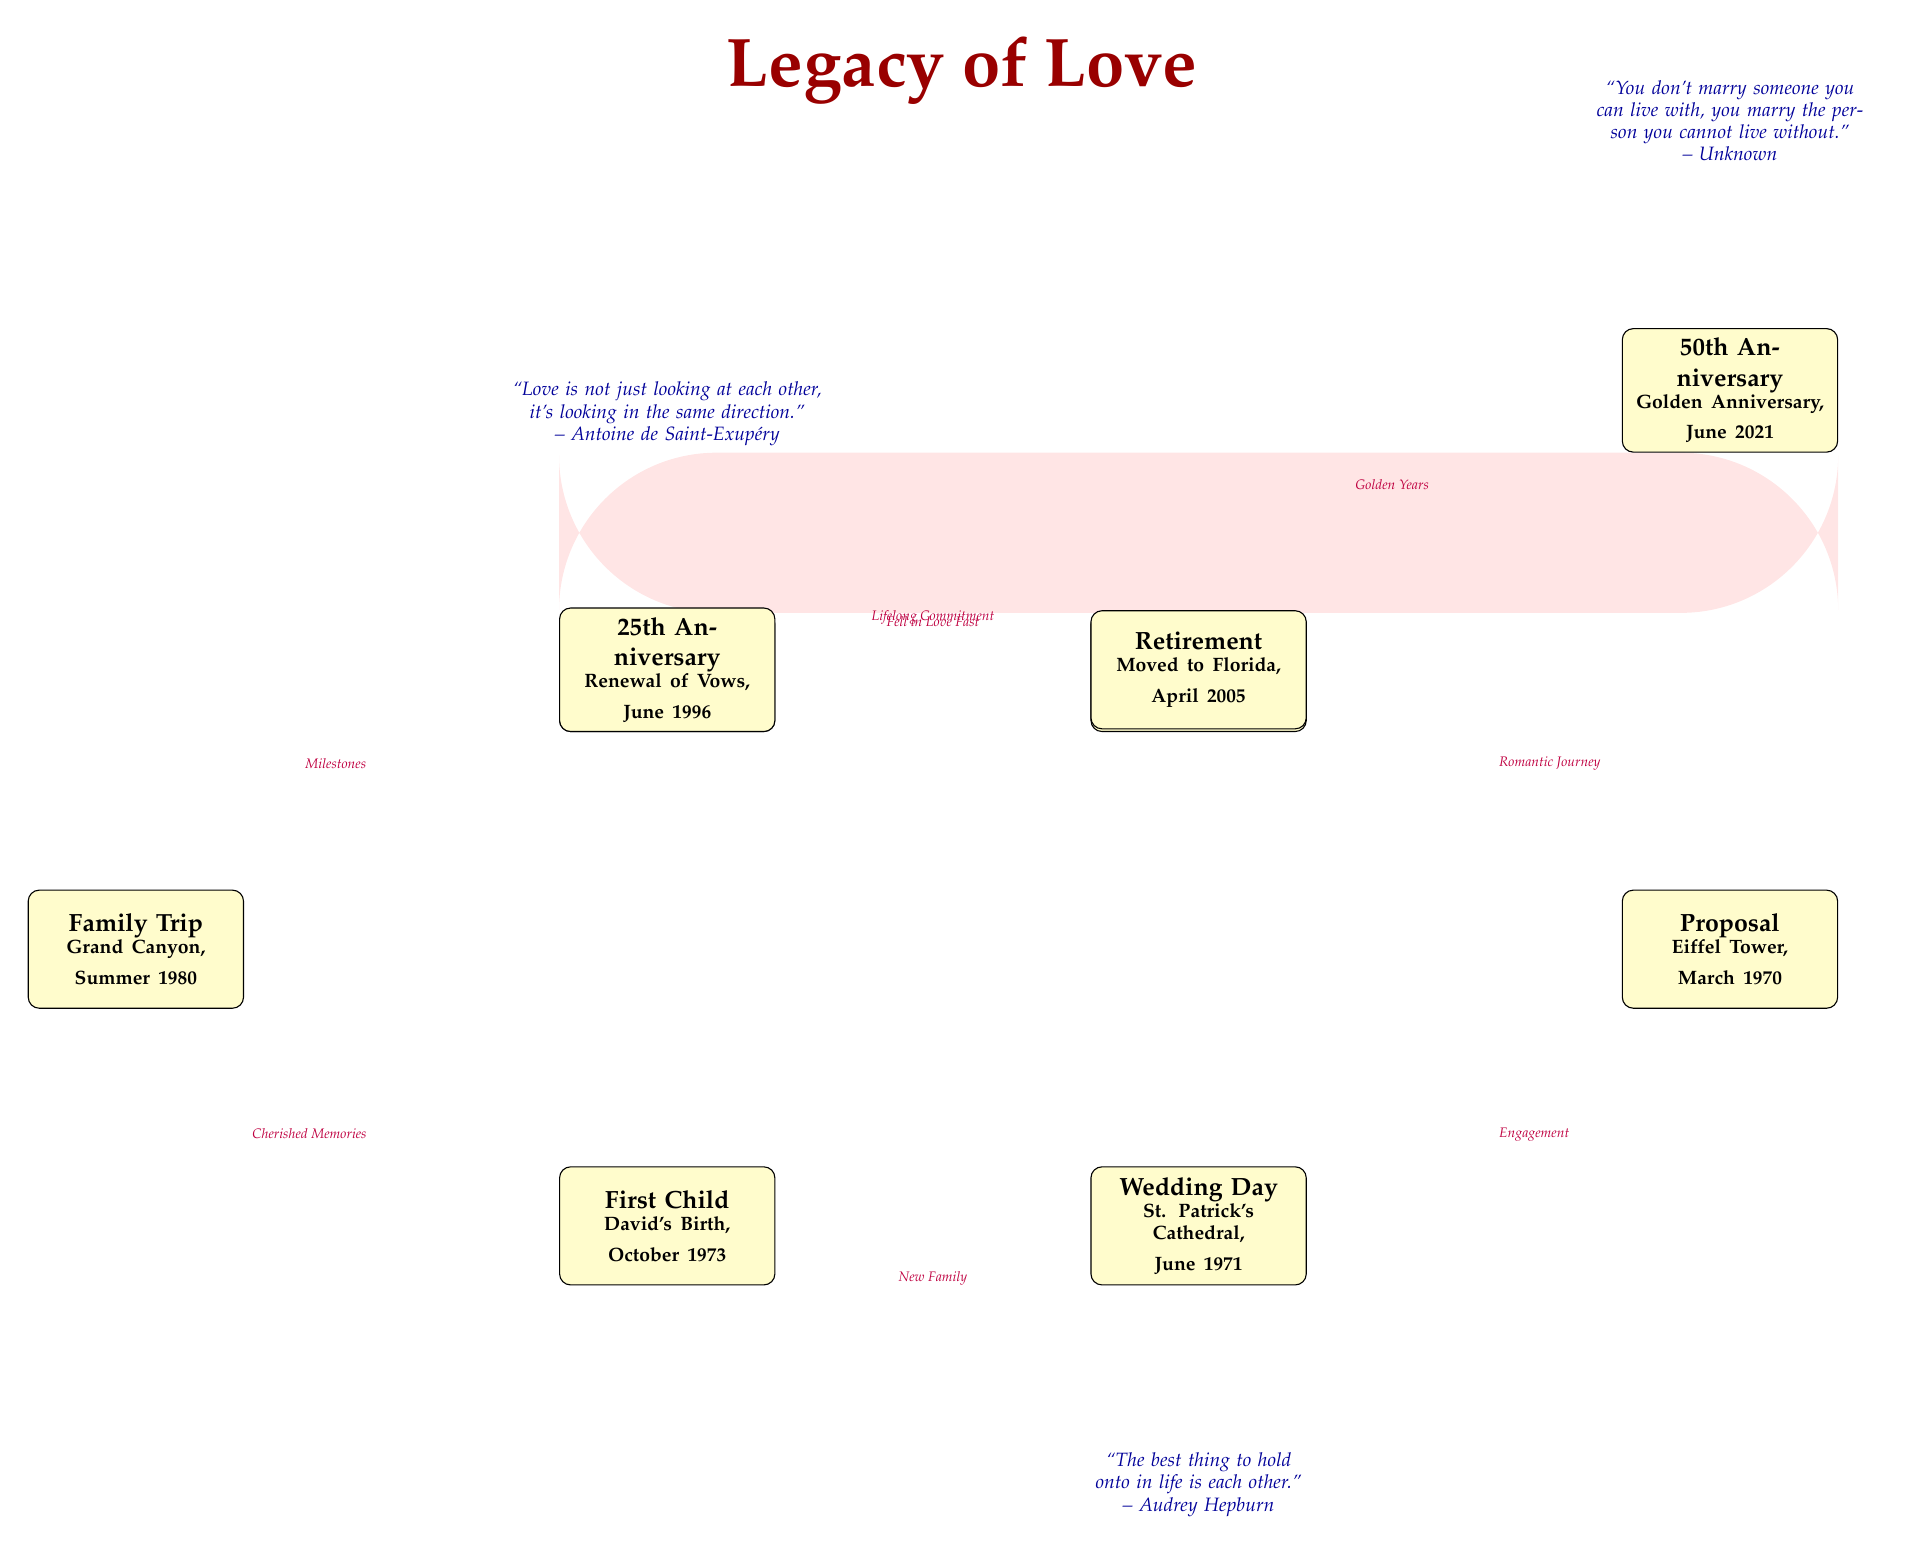What is the first event listed in the diagram? The first event node is labeled "First Meeting" and is located at the top left of the diagram. This indicates that it chronologically represents the starting point of the couple's love story.
Answer: First Meeting What significant location is mentioned for the wedding? The wedding event is indicated with a location "St. Patrick's Cathedral" written under the "Wedding Day" event. This specifies the venue where this important ceremony took place.
Answer: St. Patrick's Cathedral How many total events are illustrated in the diagram? By counting the event nodes, which include items like "First Meeting" through "50th Anniversary", we find there are a total of 8 events depicted in the diagram.
Answer: 8 What does the connection from "First Date" to "Proposal" signify? The connection is labeled "Romantic Journey," signifying the development of their relationship in between these two significant events, suggesting that their bond deepened over time before the proposal.
Answer: Romantic Journey What quote is associated with the beginning of the couple's journey? The quote located above the "First Meeting" event states: "Love is not just looking at each other, it's looking in the same direction," affirming the foundation of their relationship.
Answer: Love is not just looking at each other, it's looking in the same direction Which event immediately follows the "Wedding Day"? Following the "Wedding Day" in the diagram, the next event shown is the "First Child", indicating the subsequent step in their life together as a married couple.
Answer: First Child What connection leads to "Family Trip" and what does it represent? The connection leading to "Family Trip" is marked "Cherished Memories," representing the meaningful experiences the couple shared with their child, enhancing their family bond.
Answer: Cherished Memories What is the date of the 50th Anniversary celebration? The date specified in the diagram for the "50th Anniversary" event is June 2021, signifying a milestone celebration in their relationship.
Answer: June 2021 What is the last event shown in the "Legacy of Love" diagram? The last event node depicted in the diagram is the "50th Anniversary," marking the culmination of the couple's journey and the legacy they built together over the years.
Answer: 50th Anniversary 